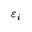Convert formula to latex. <formula><loc_0><loc_0><loc_500><loc_500>\varepsilon _ { i }</formula> 